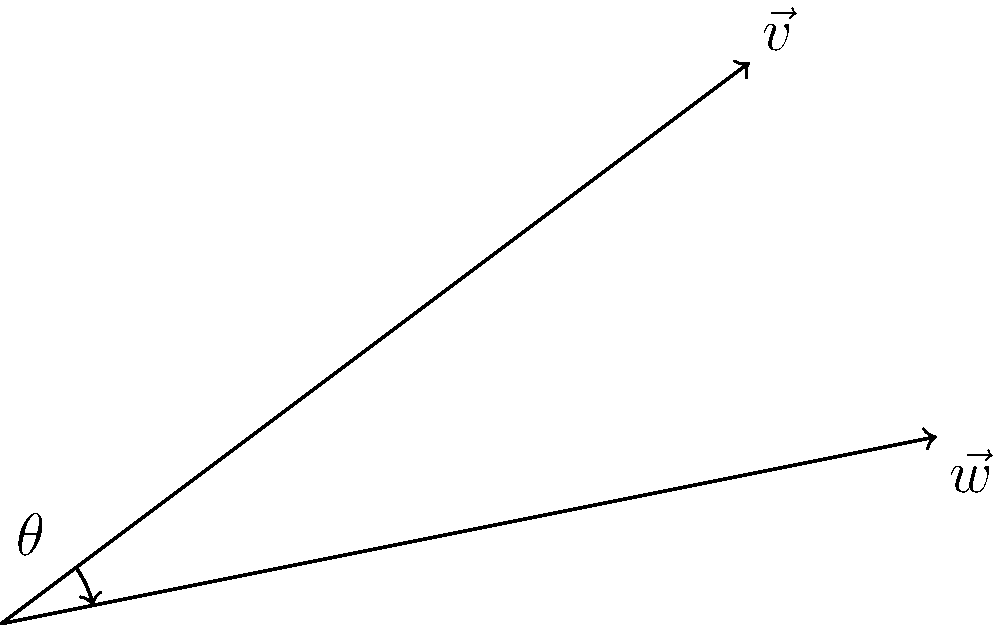In Théodore Géricault's "The Raft of the Medusa," two prominent diagonal lines can be represented by vectors $\vec{v} = \langle 4, 3 \rangle$ and $\vec{w} = \langle 5, 1 \rangle$. Calculate the angle $\theta$ between these vectors, rounded to the nearest degree. To find the angle between two vectors, we can use the dot product formula:

$$\cos \theta = \frac{\vec{v} \cdot \vec{w}}{|\vec{v}| |\vec{w}|}$$

Step 1: Calculate the dot product $\vec{v} \cdot \vec{w}$
$$\vec{v} \cdot \vec{w} = (4)(5) + (3)(1) = 20 + 3 = 23$$

Step 2: Calculate the magnitudes of $\vec{v}$ and $\vec{w}$
$$|\vec{v}| = \sqrt{4^2 + 3^2} = \sqrt{16 + 9} = \sqrt{25} = 5$$
$$|\vec{w}| = \sqrt{5^2 + 1^2} = \sqrt{25 + 1} = \sqrt{26}$$

Step 3: Apply the dot product formula
$$\cos \theta = \frac{23}{5\sqrt{26}}$$

Step 4: Take the inverse cosine (arccos) of both sides
$$\theta = \arccos\left(\frac{23}{5\sqrt{26}}\right)$$

Step 5: Calculate and round to the nearest degree
$$\theta \approx 23.4° \approx 23°$$
Answer: 23° 